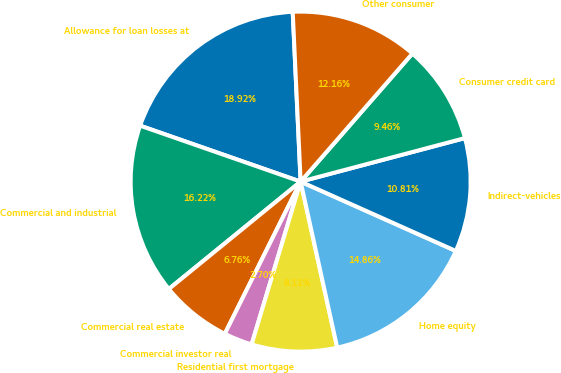<chart> <loc_0><loc_0><loc_500><loc_500><pie_chart><fcel>Allowance for loan losses at<fcel>Commercial and industrial<fcel>Commercial real estate<fcel>Commercial investor real<fcel>Residential first mortgage<fcel>Home equity<fcel>Indirect-vehicles<fcel>Consumer credit card<fcel>Other consumer<nl><fcel>18.92%<fcel>16.22%<fcel>6.76%<fcel>2.7%<fcel>8.11%<fcel>14.86%<fcel>10.81%<fcel>9.46%<fcel>12.16%<nl></chart> 